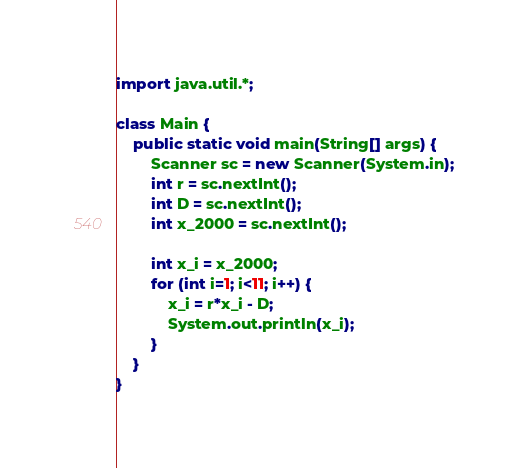<code> <loc_0><loc_0><loc_500><loc_500><_Java_>import java.util.*;

class Main {
    public static void main(String[] args) {
        Scanner sc = new Scanner(System.in);
        int r = sc.nextInt();
        int D = sc.nextInt();
        int x_2000 = sc.nextInt();

        int x_i = x_2000;
        for (int i=1; i<11; i++) {
            x_i = r*x_i - D;
            System.out.println(x_i);
        }
    }
}
</code> 